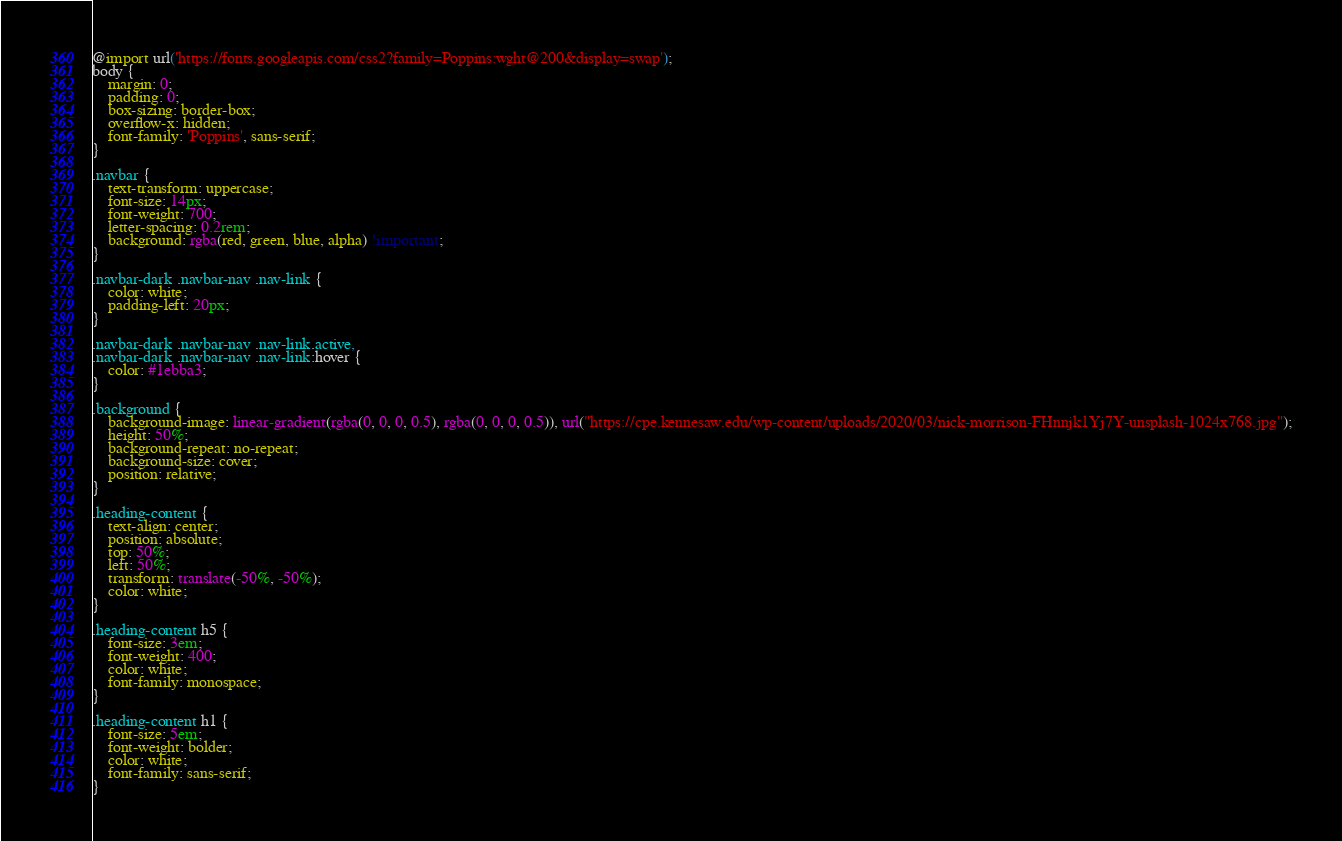<code> <loc_0><loc_0><loc_500><loc_500><_CSS_>@import url('https://fonts.googleapis.com/css2?family=Poppins:wght@200&display=swap');
body {
    margin: 0;
    padding: 0;
    box-sizing: border-box;
    overflow-x: hidden;
    font-family: 'Poppins', sans-serif;
}

.navbar {
    text-transform: uppercase;
    font-size: 14px;
    font-weight: 700;
    letter-spacing: 0.2rem;
    background: rgba(red, green, blue, alpha) !important;
}

.navbar-dark .navbar-nav .nav-link {
    color: white;
    padding-left: 20px;
}

.navbar-dark .navbar-nav .nav-link.active,
.navbar-dark .navbar-nav .nav-link:hover {
    color: #1ebba3;
}

.background {
    background-image: linear-gradient(rgba(0, 0, 0, 0.5), rgba(0, 0, 0, 0.5)), url("https://cpe.kennesaw.edu/wp-content/uploads/2020/03/nick-morrison-FHnnjk1Yj7Y-unsplash-1024x768.jpg");
    height: 50%;
    background-repeat: no-repeat;
    background-size: cover;
    position: relative;
}

.heading-content {
    text-align: center;
    position: absolute;
    top: 50%;
    left: 50%;
    transform: translate(-50%, -50%);
    color: white;
}

.heading-content h5 {
    font-size: 3em;
    font-weight: 400;
    color: white;
    font-family: monospace;
}

.heading-content h1 {
    font-size: 5em;
    font-weight: bolder;
    color: white;
    font-family: sans-serif;
}</code> 